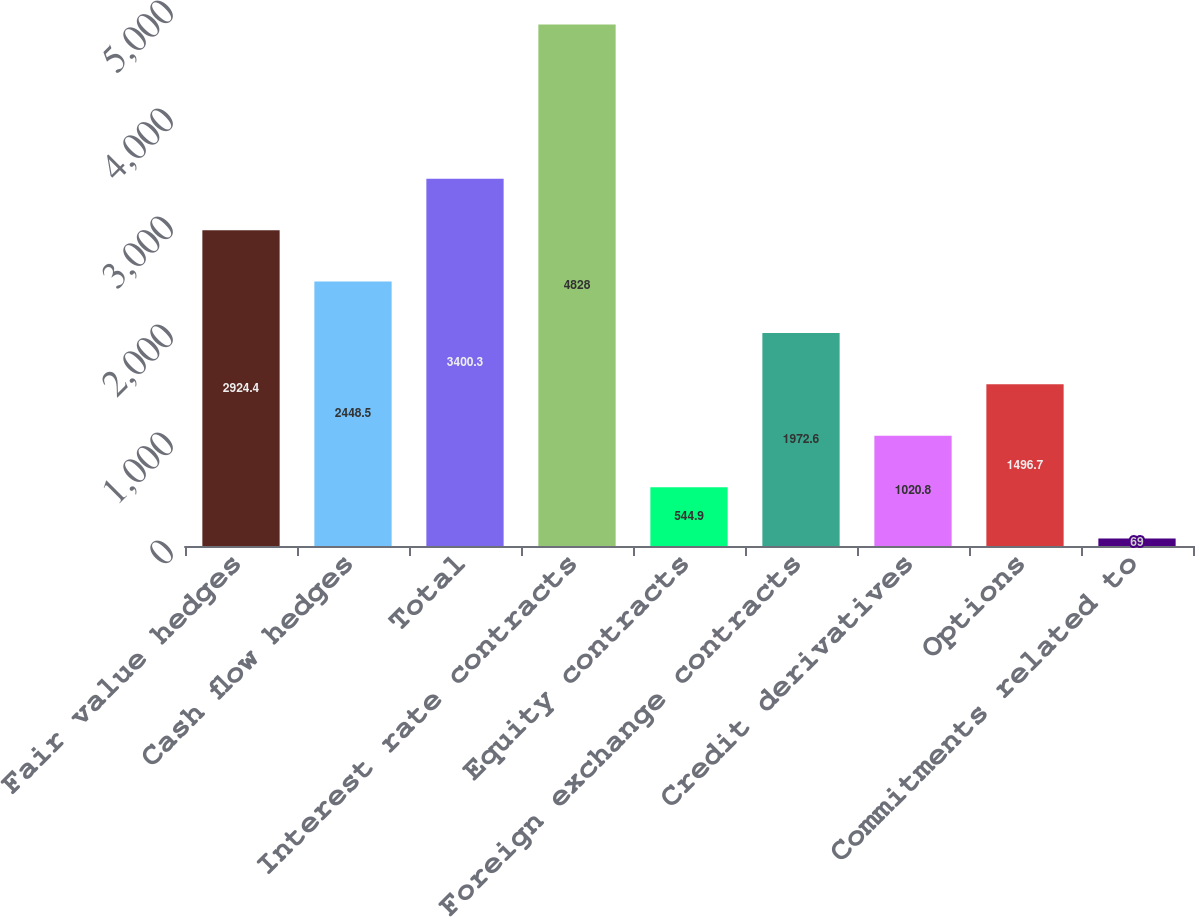<chart> <loc_0><loc_0><loc_500><loc_500><bar_chart><fcel>Fair value hedges<fcel>Cash flow hedges<fcel>Total<fcel>Interest rate contracts<fcel>Equity contracts<fcel>Foreign exchange contracts<fcel>Credit derivatives<fcel>Options<fcel>Commitments related to<nl><fcel>2924.4<fcel>2448.5<fcel>3400.3<fcel>4828<fcel>544.9<fcel>1972.6<fcel>1020.8<fcel>1496.7<fcel>69<nl></chart> 